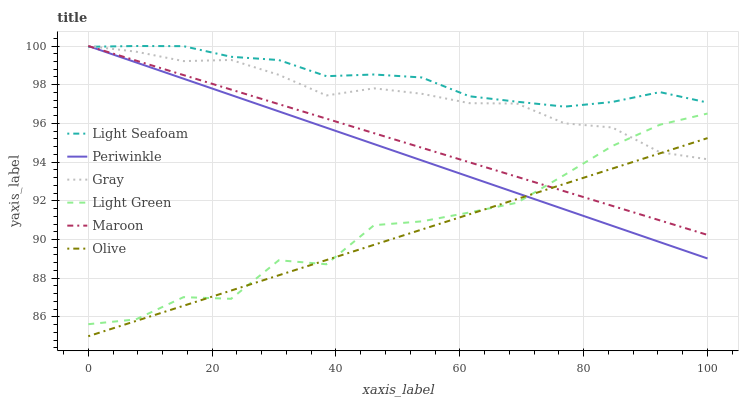Does Olive have the minimum area under the curve?
Answer yes or no. Yes. Does Light Seafoam have the maximum area under the curve?
Answer yes or no. Yes. Does Maroon have the minimum area under the curve?
Answer yes or no. No. Does Maroon have the maximum area under the curve?
Answer yes or no. No. Is Maroon the smoothest?
Answer yes or no. Yes. Is Light Green the roughest?
Answer yes or no. Yes. Is Periwinkle the smoothest?
Answer yes or no. No. Is Periwinkle the roughest?
Answer yes or no. No. Does Maroon have the lowest value?
Answer yes or no. No. Does Light Seafoam have the highest value?
Answer yes or no. Yes. Does Light Green have the highest value?
Answer yes or no. No. Is Olive less than Light Seafoam?
Answer yes or no. Yes. Is Light Seafoam greater than Olive?
Answer yes or no. Yes. Does Olive intersect Light Seafoam?
Answer yes or no. No. 